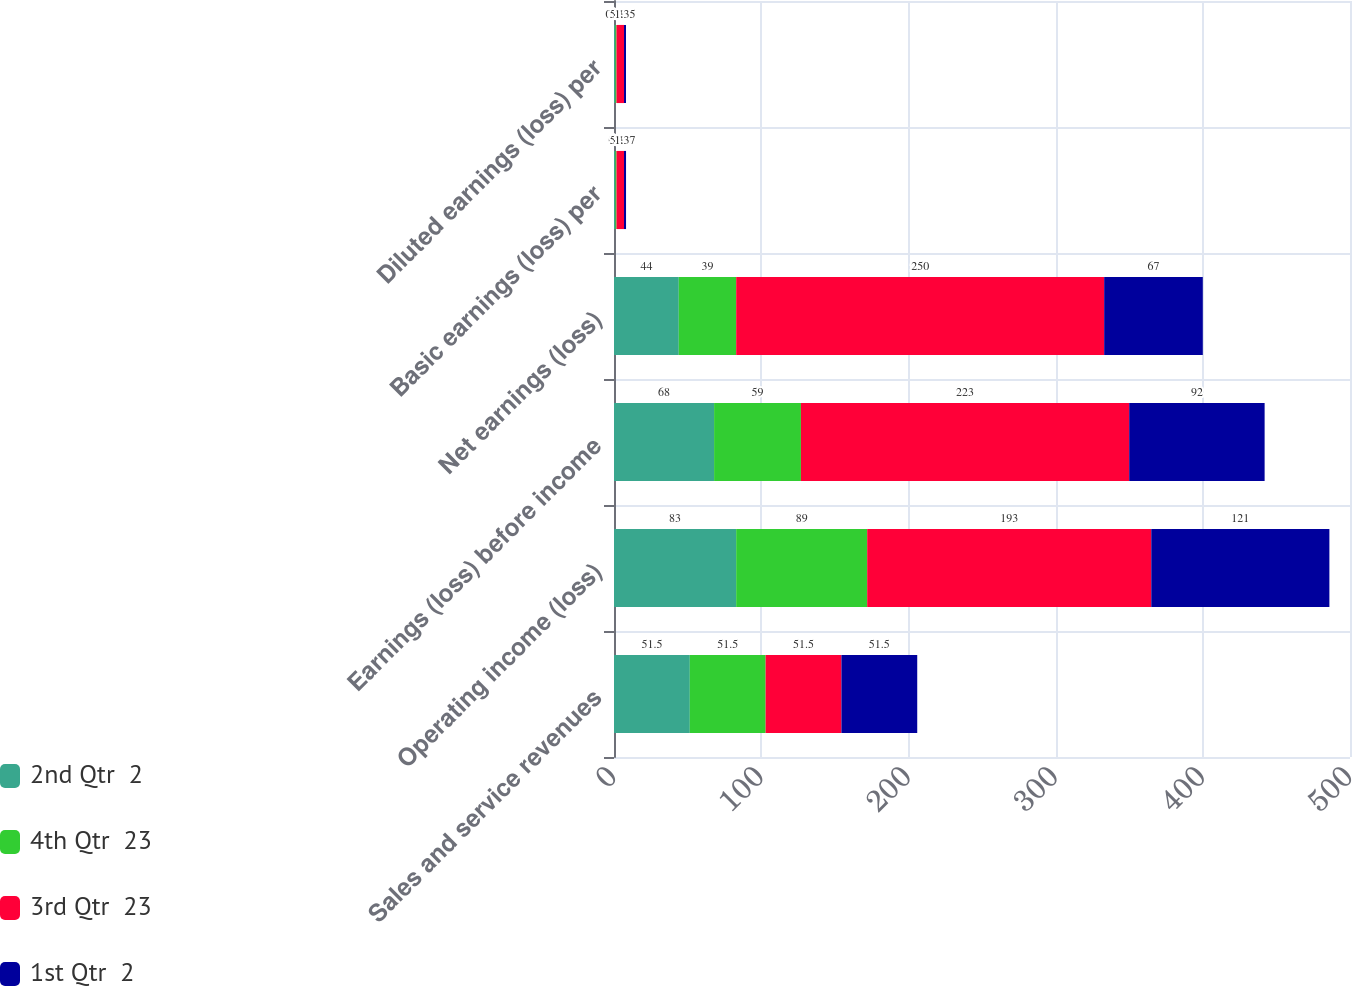<chart> <loc_0><loc_0><loc_500><loc_500><stacked_bar_chart><ecel><fcel>Sales and service revenues<fcel>Operating income (loss)<fcel>Earnings (loss) before income<fcel>Net earnings (loss)<fcel>Basic earnings (loss) per<fcel>Diluted earnings (loss) per<nl><fcel>2nd Qtr  2<fcel>51.5<fcel>83<fcel>68<fcel>44<fcel>0.9<fcel>0.9<nl><fcel>4th Qtr  23<fcel>51.5<fcel>89<fcel>59<fcel>39<fcel>0.8<fcel>0.79<nl><fcel>3rd Qtr  23<fcel>51.5<fcel>193<fcel>223<fcel>250<fcel>5.11<fcel>5.11<nl><fcel>1st Qtr  2<fcel>51.5<fcel>121<fcel>92<fcel>67<fcel>1.37<fcel>1.35<nl></chart> 